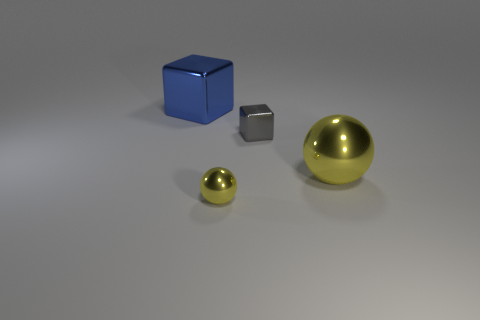Add 4 yellow metallic objects. How many objects exist? 8 Add 4 big yellow things. How many big yellow things are left? 5 Add 1 big things. How many big things exist? 3 Subtract 0 brown cylinders. How many objects are left? 4 Subtract all large blue shiny things. Subtract all metal cubes. How many objects are left? 1 